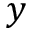Convert formula to latex. <formula><loc_0><loc_0><loc_500><loc_500>y</formula> 